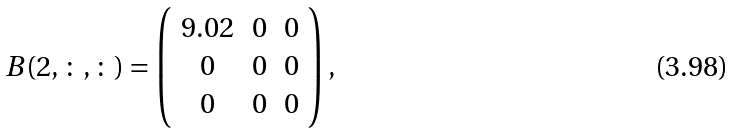<formula> <loc_0><loc_0><loc_500><loc_500>B ( 2 , \colon , \colon ) = \left ( \begin{array} { c c c } 9 . 0 2 & 0 & 0 \\ 0 & 0 & 0 \\ 0 & 0 & 0 \end{array} \right ) ,</formula> 